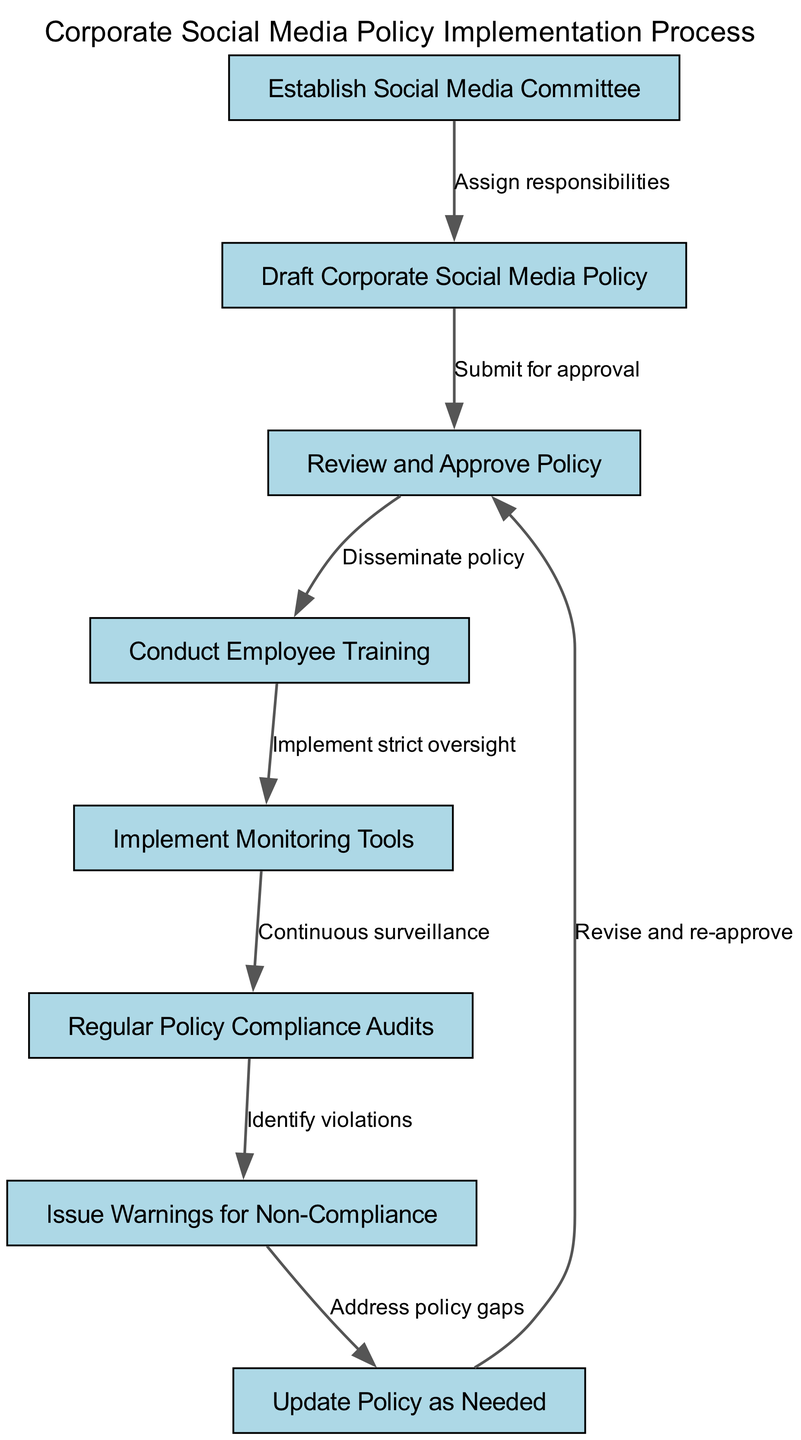What is the first step in the process? The first step is indicated by the node with ID 1, which states "Establish Social Media Committee." This is the starting point of the flow, showing the initial action that needs to be taken.
Answer: Establish Social Media Committee How many nodes are present in the diagram? By counting the nodes listed, we find there are a total of 8 nodes in the diagram describing various steps in the process.
Answer: 8 What action follows after conducting employee training? The edge from node 4 to node 5 indicates the next action after training is to "Implement Monitoring Tools," showing the flow from one action to the next in the process.
Answer: Implement Monitoring Tools What is the relationship between 'Review and Approve Policy' and 'Draft Corporate Social Media Policy'? The relationship is defined by the directed edge that connects these two nodes, indicating that the "Draft Corporate Social Media Policy" must be "Submitted for approval" before it can be reviewed and approved.
Answer: Submit for approval What is the last action taken in the process? The last action is represented by the node with ID 8, which states "Update Policy as Needed." This indicates that after identifying violations, the policy may require updates, closing the process loop by returning to the approval stage.
Answer: Update Policy as Needed What happens if non-compliance is identified? According to the edge from node 6 to node 7, if non-compliance is identified during audits, the next step is to "Issue Warnings for Non-Compliance," highlighting a consequence of policy violations.
Answer: Issue Warnings for Non-Compliance Which step involves continuous surveillance? The step that involves continuous surveillance is indicated by the edge from node 5 to node 6, where the action taken after implementing monitoring tools is to perform "Regular Policy Compliance Audits."
Answer: Regular Policy Compliance Audits What must be done if there are policy gaps? If there are identified policy gaps, as indicated by the edge from node 7 to node 8, it states that the necessary action is to "Address policy gaps," leading to the update and re-approval of the policy later.
Answer: Address policy gaps 